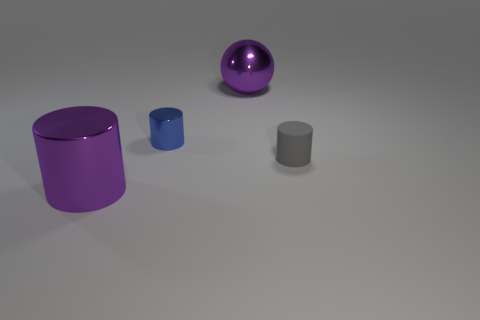Subtract all big shiny cylinders. How many cylinders are left? 2 Subtract all gray cylinders. How many cylinders are left? 2 Subtract all balls. How many objects are left? 3 Subtract 1 balls. How many balls are left? 0 Add 3 tiny red matte spheres. How many tiny red matte spheres exist? 3 Add 1 blue shiny things. How many objects exist? 5 Subtract 1 gray cylinders. How many objects are left? 3 Subtract all red cylinders. Subtract all purple balls. How many cylinders are left? 3 Subtract all gray matte objects. Subtract all purple metal cylinders. How many objects are left? 2 Add 4 matte things. How many matte things are left? 5 